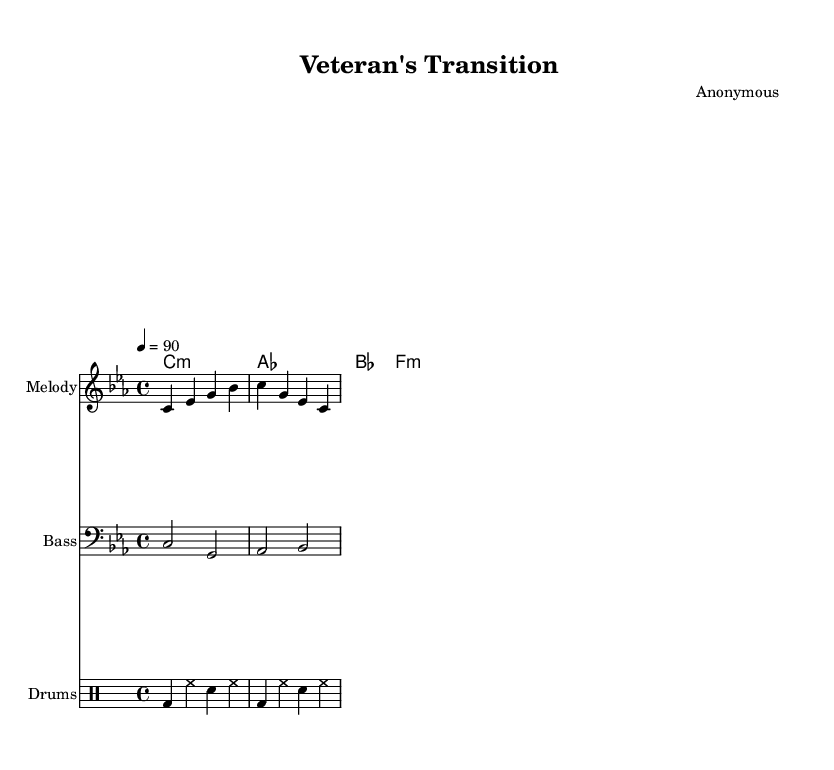What is the key signature of this music? The key signature is C minor, indicated by the presence of three flats (B♭, E♭, and A♭) in the key signature area.
Answer: C minor What is the time signature of this music? The time signature is 4/4, which is noted at the beginning of the score as the fraction 4 over 4.
Answer: 4/4 What is the tempo marking for this piece? The tempo marking indicates a tempo of 90 beats per minute, which is notated as "4 = 90" in the score.
Answer: 90 How many measures are in the melody section? The melody section consists of four measures as indicated by the four groups of notes separated by vertical lines (bar lines).
Answer: 4 What is the main theme reflected in the verse lyrics? The verse lyrics reflect the theme of transitioning from a battlefield to civilian life, highlighting the stark contrast between the two environments.
Answer: Transition What type of rhythm is represented in the drum part? The drum part features a standard hip-hop rhythm, utilizing a combination of bass drum (bd), hi-hat (hh), and snare (sn) sounds typical in rap music.
Answer: Hip-hop What chord is played during the chorus? The chord played during the chorus is F minor, as indicated in the chord names section corresponding to the lyrics.
Answer: F minor 